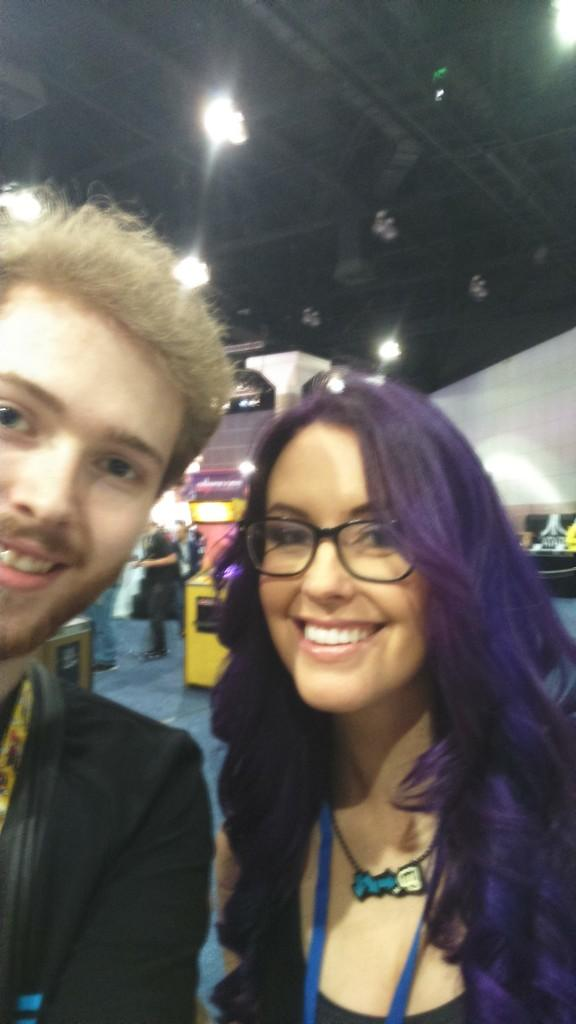How many people are present in the image? There are two people, a man and a woman, present in the image. What are the man and the woman doing in the image? Both the man and the woman are standing and smiling. What can be seen on the ceiling in the image? There are lights attached to the ceiling in the image. What type of soap is the man using in the image? There is no soap present in the image; the man and the woman are standing and smiling. Is the wine served hot or cold in the image? There is no wine present in the image; it only features a man and a woman standing and smiling. 